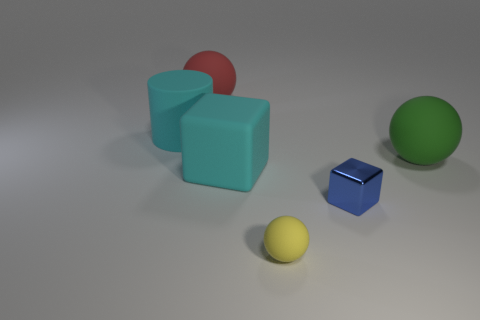Subtract all large balls. How many balls are left? 1 Add 2 cyan blocks. How many objects exist? 8 Subtract 1 spheres. How many spheres are left? 2 Subtract all cyan cubes. How many cubes are left? 1 Subtract all cylinders. How many objects are left? 5 Add 6 big cyan things. How many big cyan things are left? 8 Add 4 large green matte objects. How many large green matte objects exist? 5 Subtract 0 gray cylinders. How many objects are left? 6 Subtract all brown balls. Subtract all purple cylinders. How many balls are left? 3 Subtract all red matte objects. Subtract all rubber cubes. How many objects are left? 4 